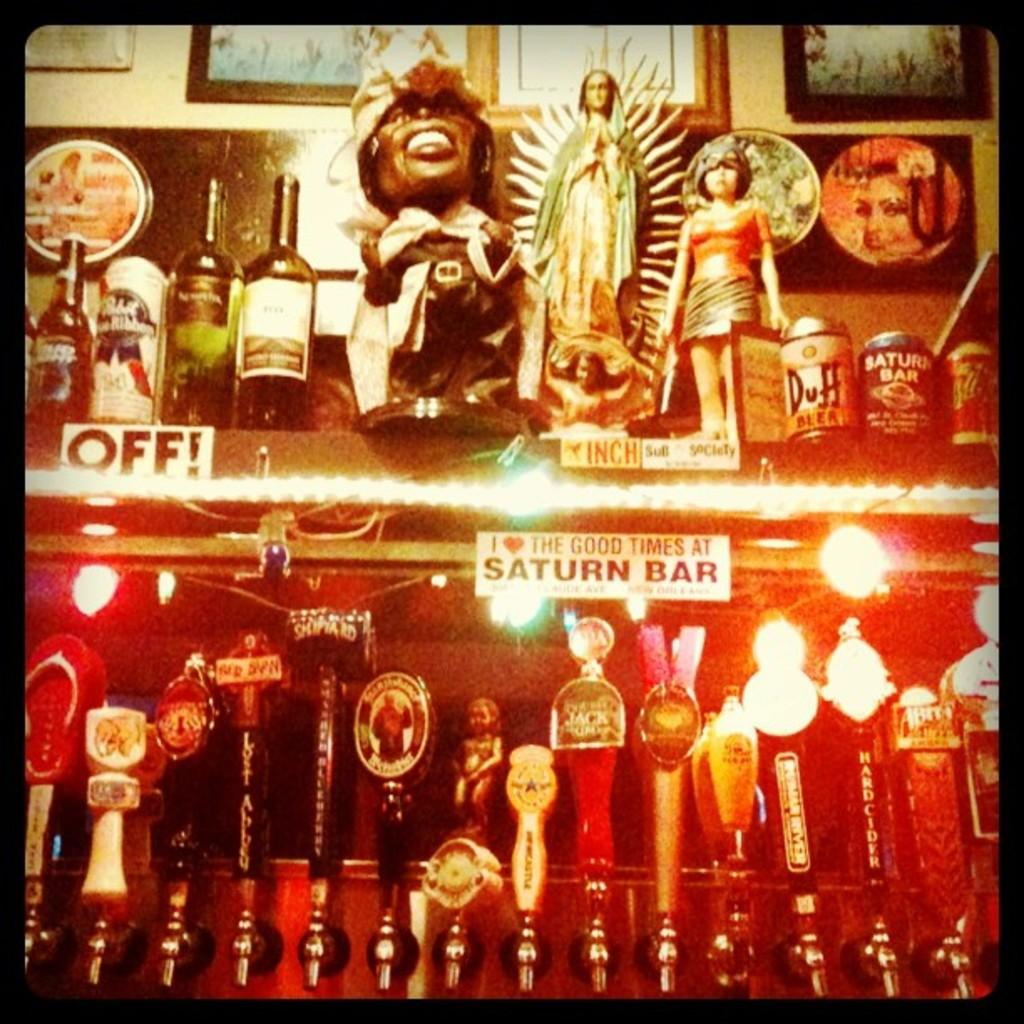<image>
Render a clear and concise summary of the photo. A sign stating I love the good times at Saturn Bar hangs next to another that has the word off on it. 